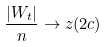<formula> <loc_0><loc_0><loc_500><loc_500>\frac { | W _ { t } | } { n } \rightarrow z ( 2 c )</formula> 